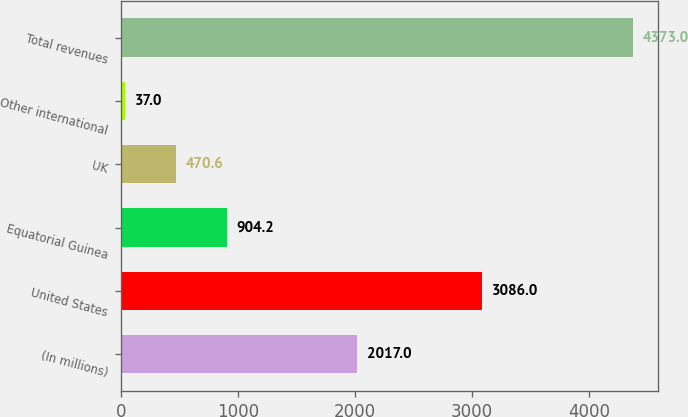Convert chart to OTSL. <chart><loc_0><loc_0><loc_500><loc_500><bar_chart><fcel>(In millions)<fcel>United States<fcel>Equatorial Guinea<fcel>UK<fcel>Other international<fcel>Total revenues<nl><fcel>2017<fcel>3086<fcel>904.2<fcel>470.6<fcel>37<fcel>4373<nl></chart> 